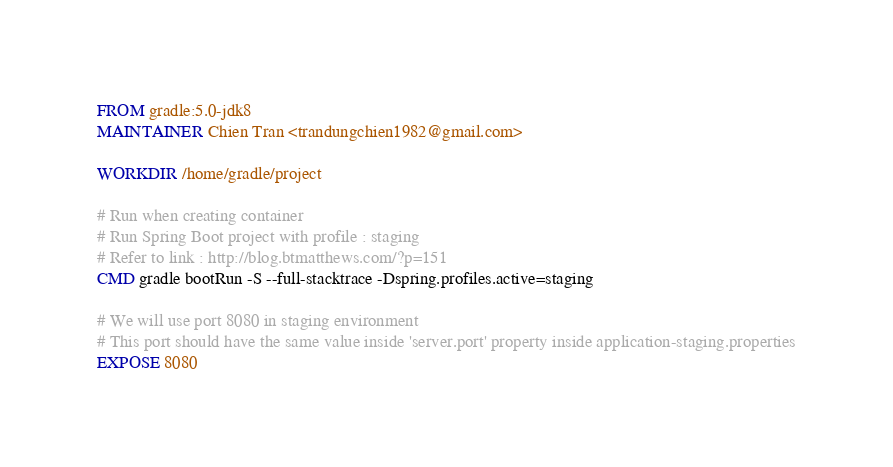<code> <loc_0><loc_0><loc_500><loc_500><_Dockerfile_>FROM gradle:5.0-jdk8
MAINTAINER Chien Tran <trandungchien1982@gmail.com>

WORKDIR /home/gradle/project

# Run when creating container
# Run Spring Boot project with profile : staging
# Refer to link : http://blog.btmatthews.com/?p=151
CMD gradle bootRun -S --full-stacktrace -Dspring.profiles.active=staging

# We will use port 8080 in staging environment
# This port should have the same value inside 'server.port' property inside application-staging.properties
EXPOSE 8080
</code> 